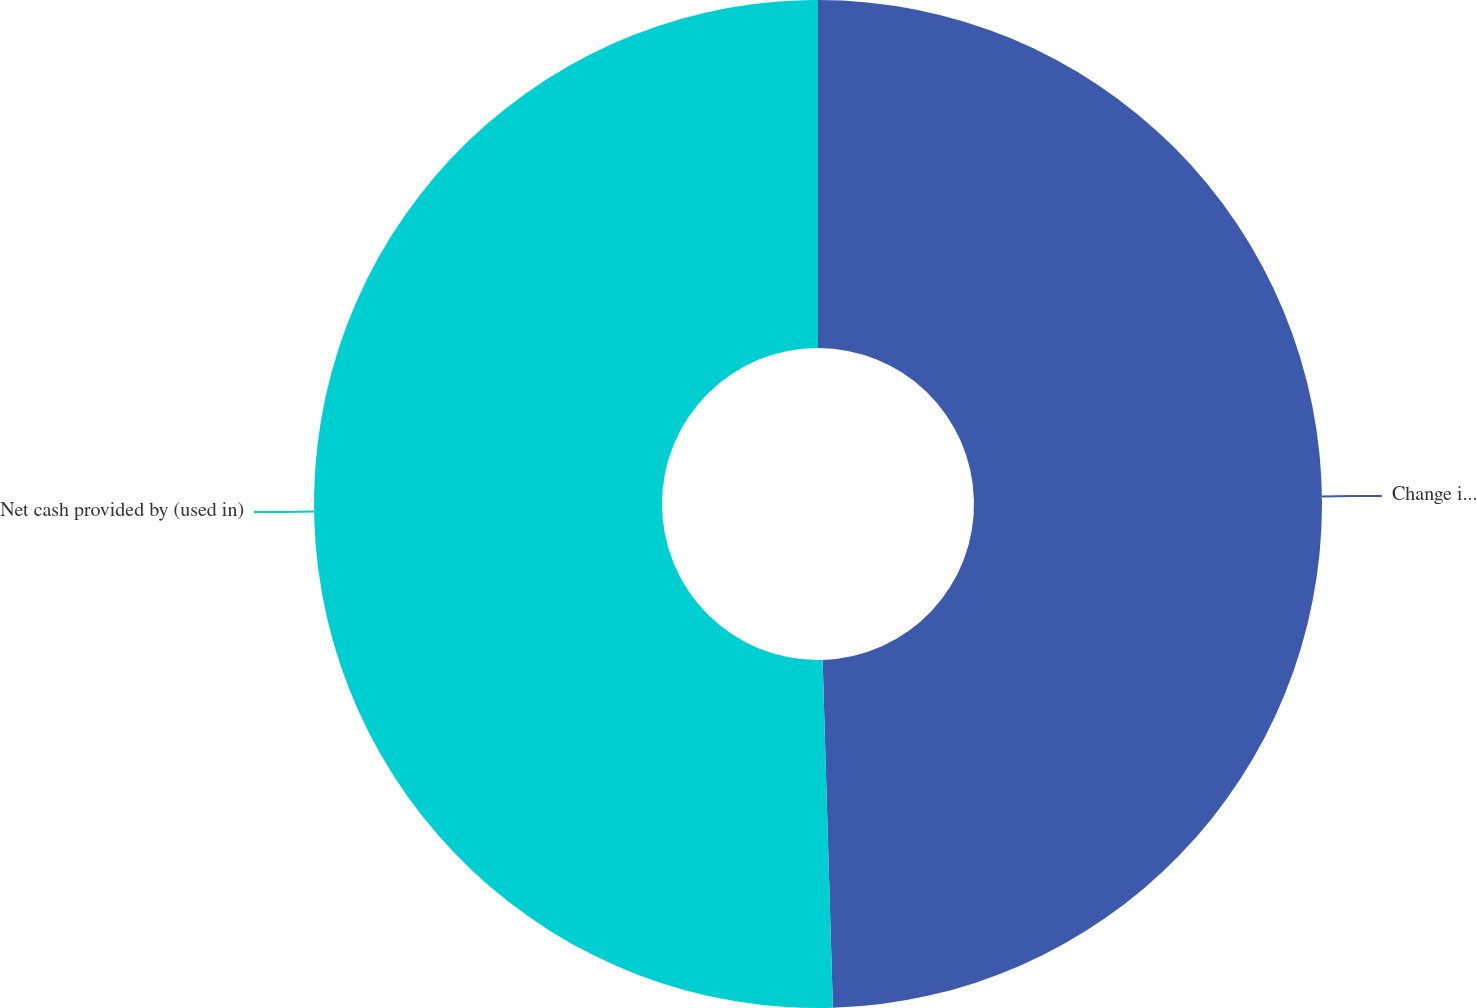Convert chart to OTSL. <chart><loc_0><loc_0><loc_500><loc_500><pie_chart><fcel>Change in other assets and<fcel>Net cash provided by (used in)<nl><fcel>49.53%<fcel>50.47%<nl></chart> 